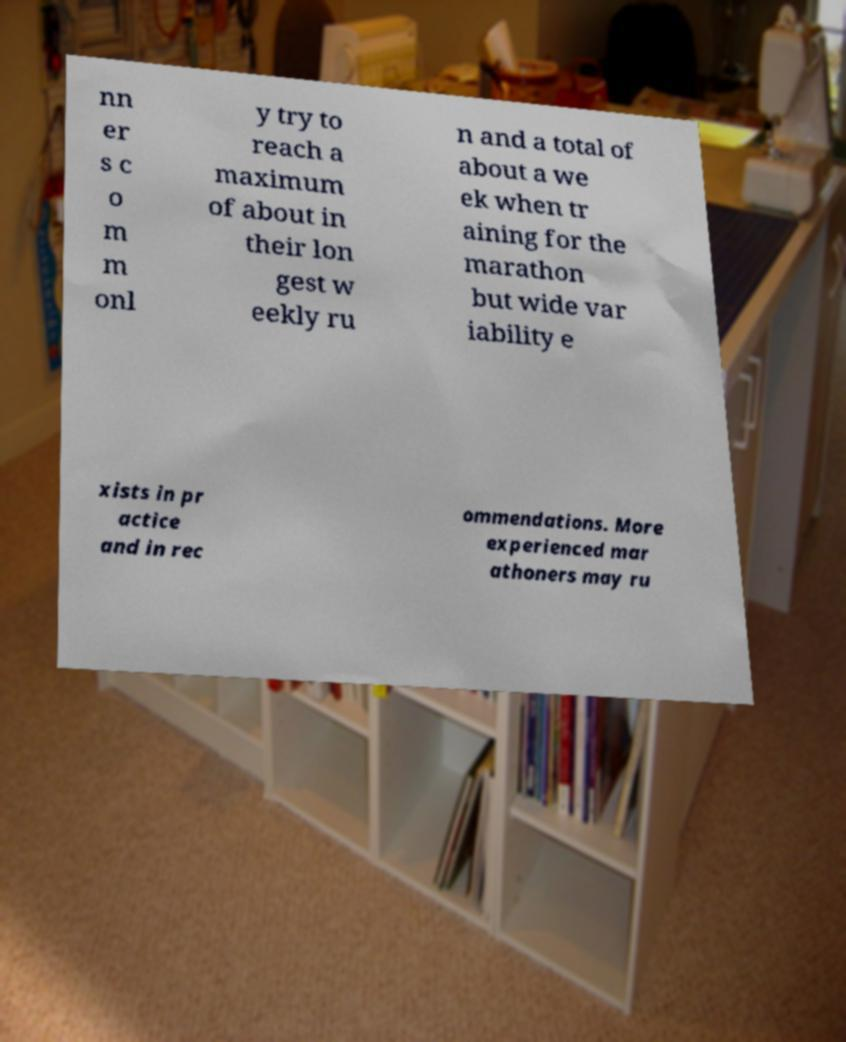Please read and relay the text visible in this image. What does it say? nn er s c o m m onl y try to reach a maximum of about in their lon gest w eekly ru n and a total of about a we ek when tr aining for the marathon but wide var iability e xists in pr actice and in rec ommendations. More experienced mar athoners may ru 